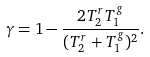<formula> <loc_0><loc_0><loc_500><loc_500>\gamma = 1 - \frac { 2 T _ { 2 } ^ { r } T _ { 1 } ^ { g } } { ( T _ { 2 } ^ { r } + T _ { 1 } ^ { g } ) ^ { 2 } } .</formula> 